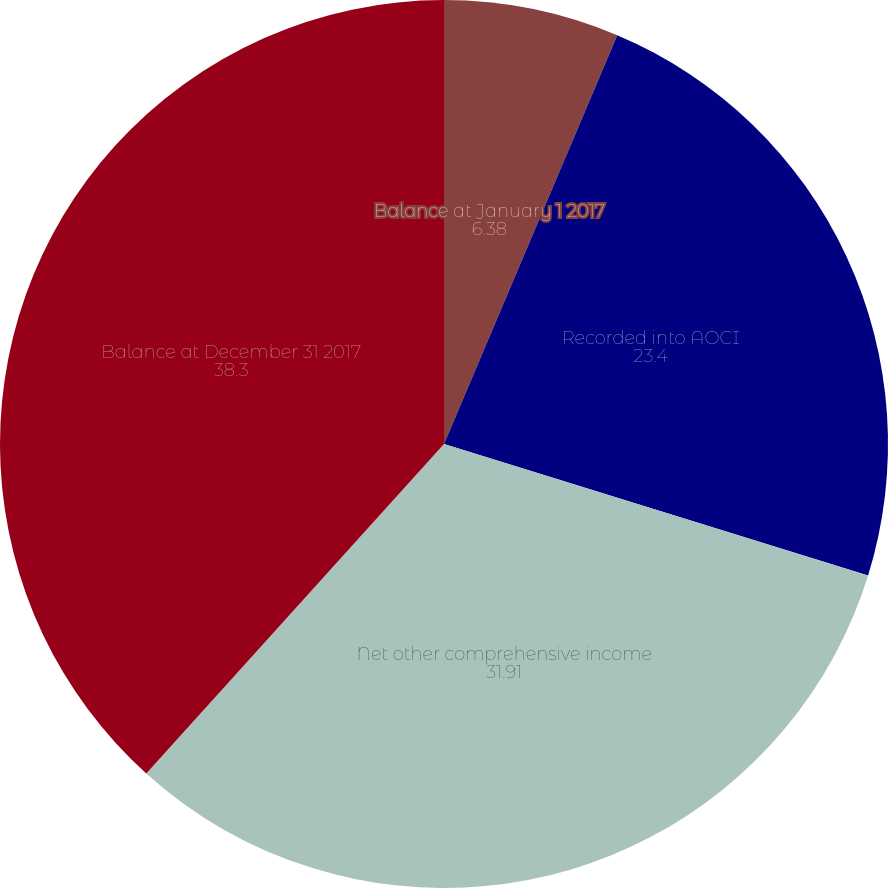Convert chart. <chart><loc_0><loc_0><loc_500><loc_500><pie_chart><fcel>Balance at January 1 2017<fcel>Recorded into AOCI<fcel>Net other comprehensive income<fcel>Balance at December 31 2017<nl><fcel>6.38%<fcel>23.4%<fcel>31.91%<fcel>38.3%<nl></chart> 